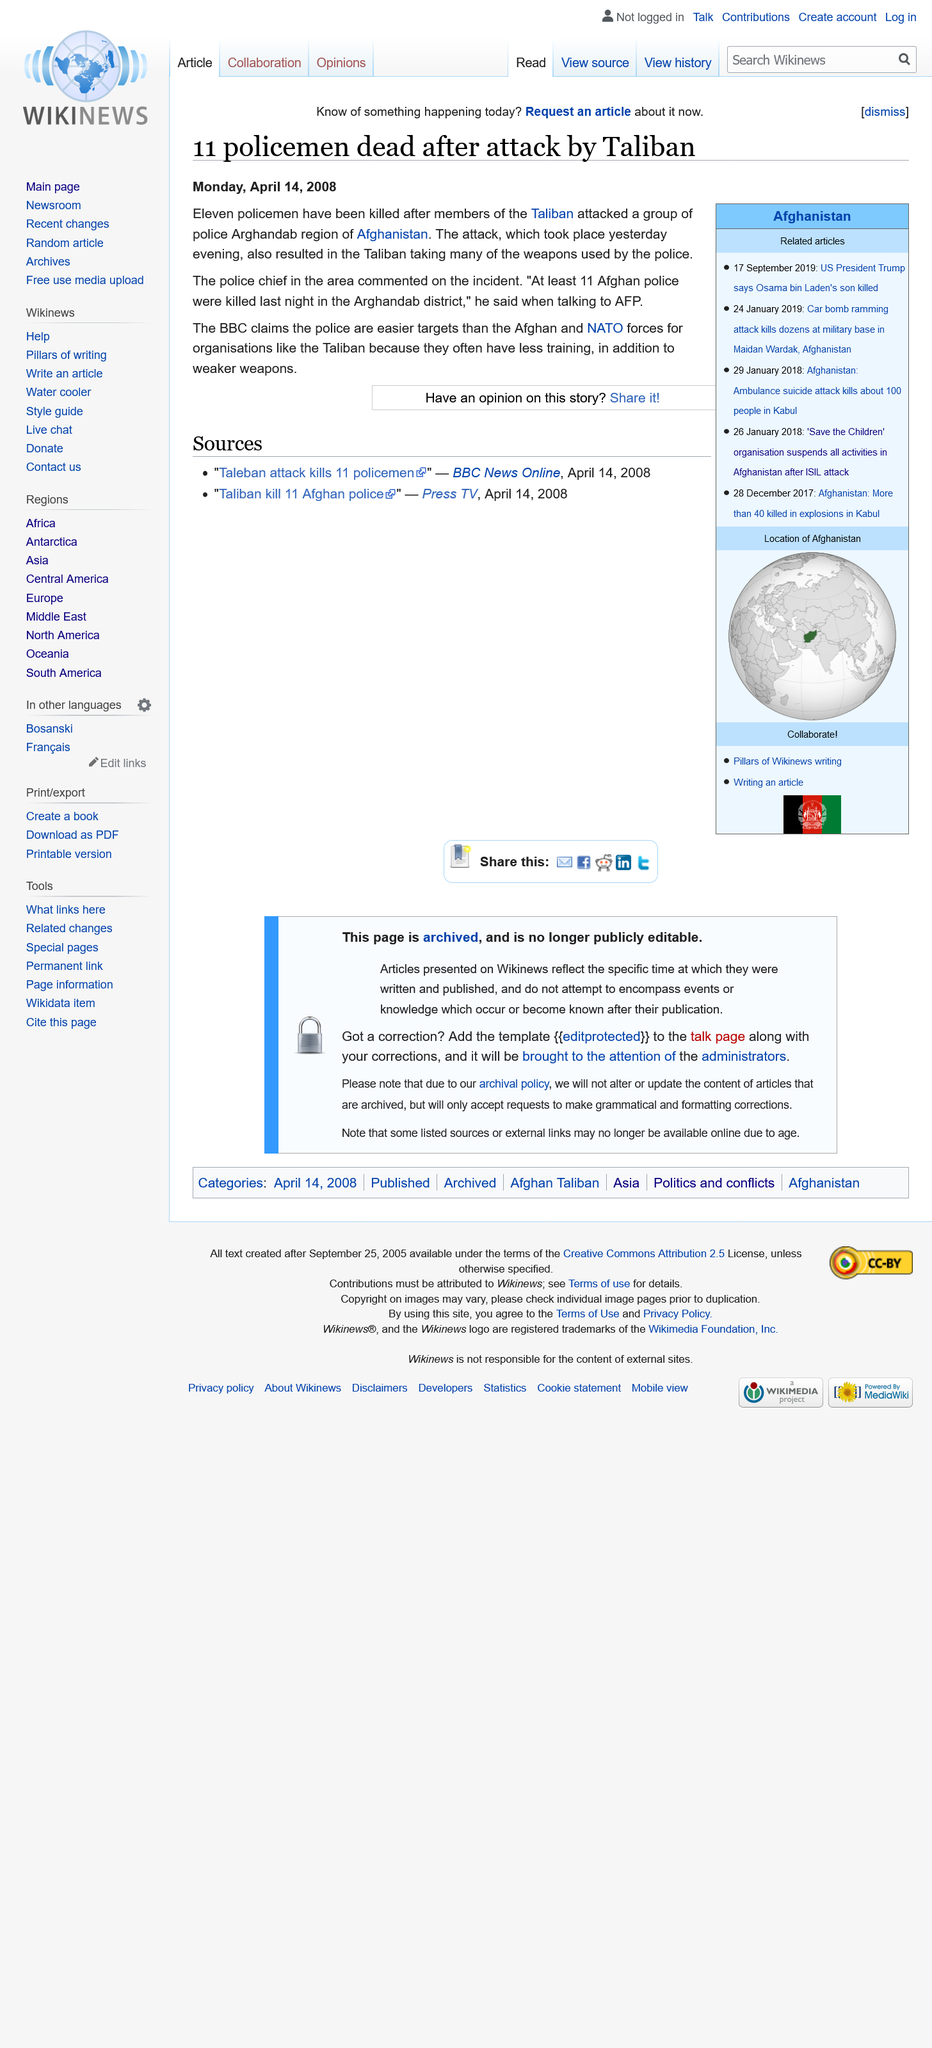Draw attention to some important aspects in this diagram. The Arghandab district was the location where 11 Afghan police members were killed. Following an attack by the Taliban, 11 policemen have lost their lives. The Taliban attacked and took the weapons of the police because the police officers were the easier targets, as reported by the BBC. 